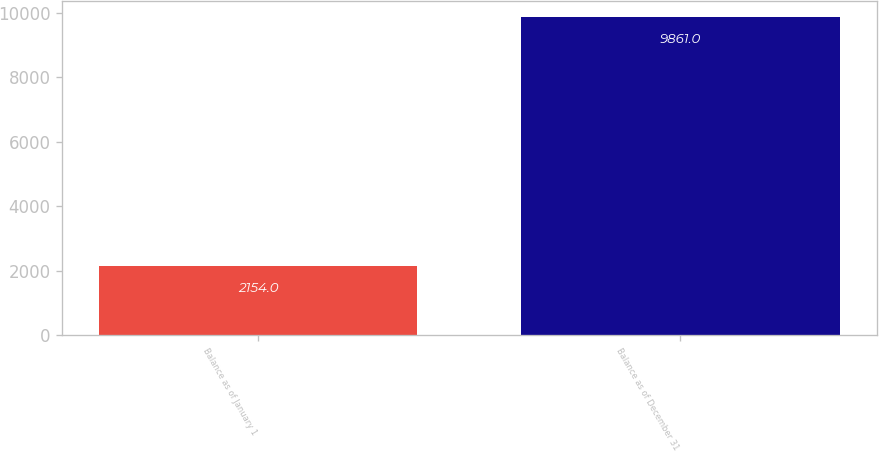Convert chart to OTSL. <chart><loc_0><loc_0><loc_500><loc_500><bar_chart><fcel>Balance as of January 1<fcel>Balance as of December 31<nl><fcel>2154<fcel>9861<nl></chart> 